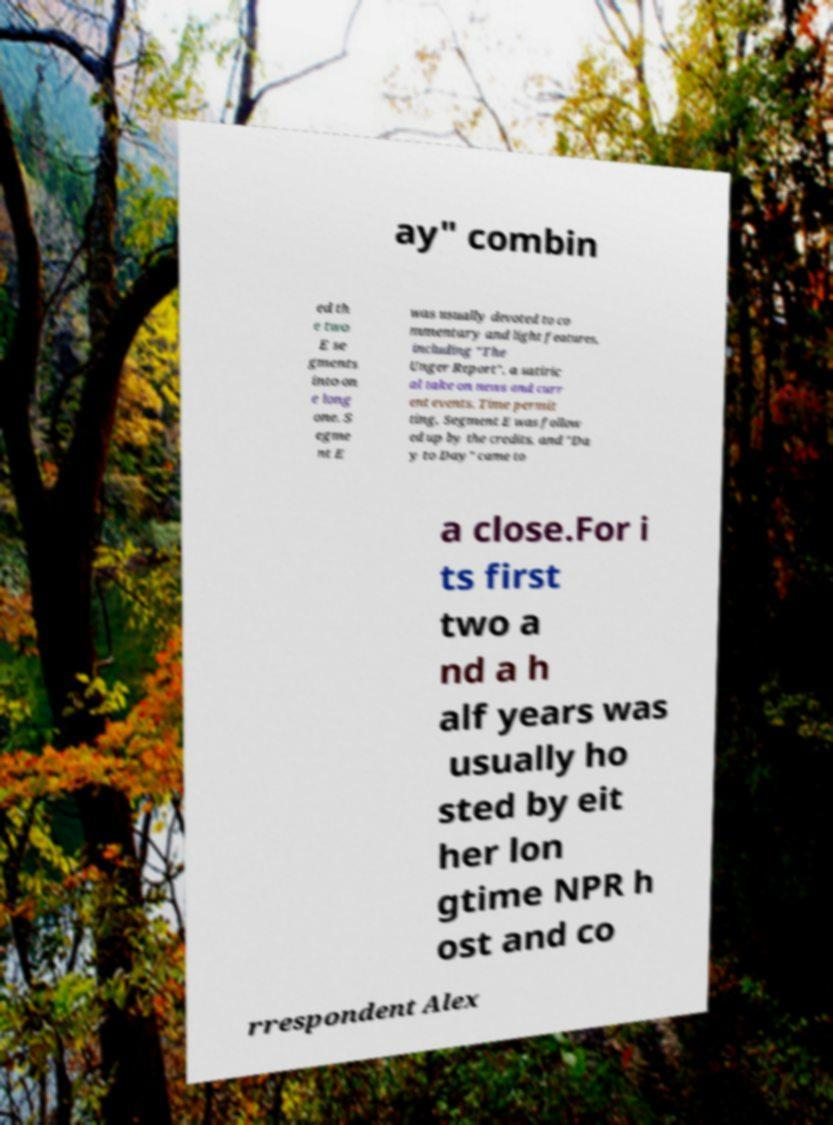Can you read and provide the text displayed in the image?This photo seems to have some interesting text. Can you extract and type it out for me? ay" combin ed th e two E se gments into on e long one. S egme nt E was usually devoted to co mmentary and light features, including "The Unger Report", a satiric al take on news and curr ent events. Time permit ting, Segment E was follow ed up by the credits, and "Da y to Day" came to a close.For i ts first two a nd a h alf years was usually ho sted by eit her lon gtime NPR h ost and co rrespondent Alex 